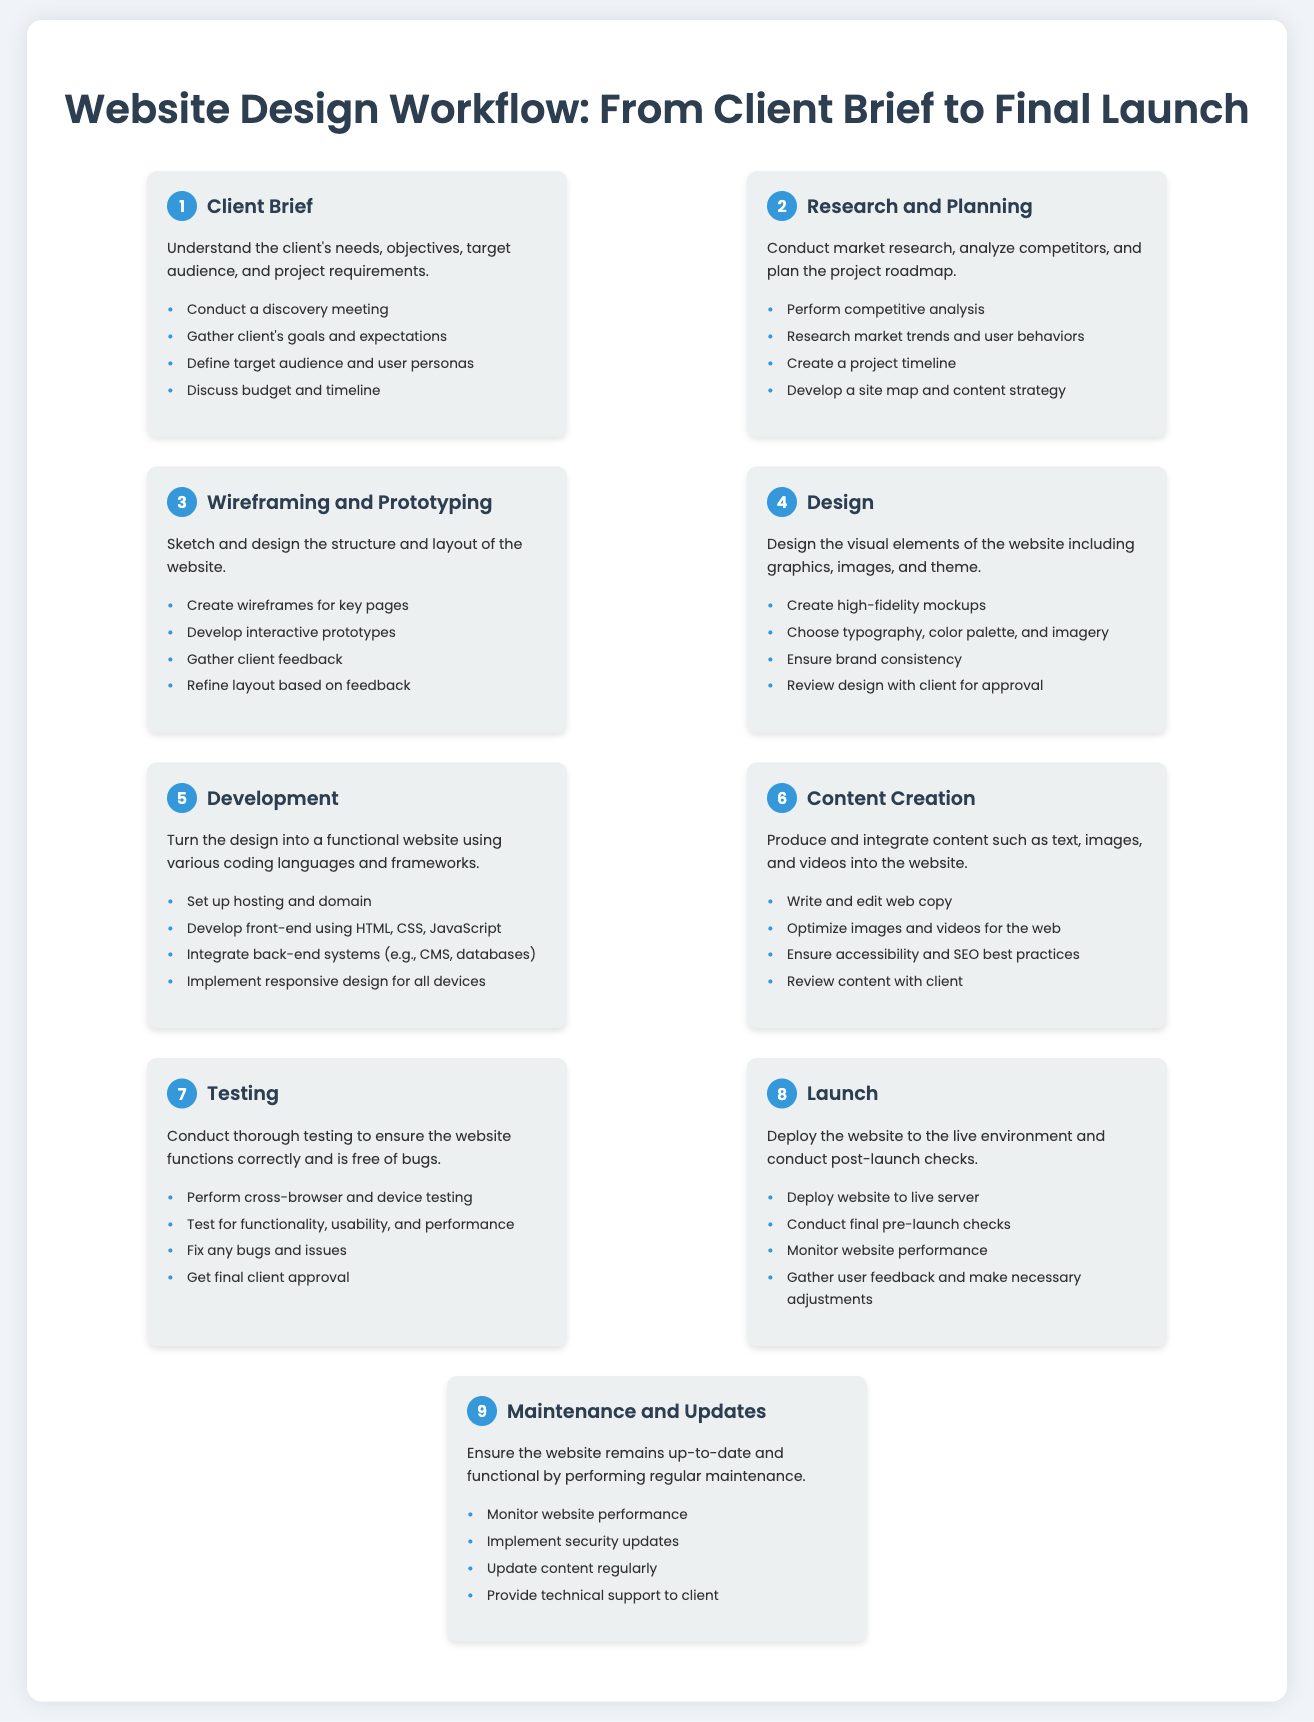What is the first step in the workflow? The first step is described in the workflow as "Client Brief", which is the initial stage in the website design process.
Answer: Client Brief How many steps are involved in the workflow? The workflow consists of a total of nine distinct steps detailing the process from start to finish.
Answer: 9 What does the "Design" step focus on? The "Design" step centers on the visual elements of the website, including graphics, images, and theme creation.
Answer: Visual elements Which step involves conducting a discovery meeting? The "Client Brief" step is where a discovery meeting is conducted to understand the client's needs and expectations.
Answer: Client Brief What is the last step mentioned in the workflow? The last step in the workflow focuses on ongoing site maintenance and updates to ensure functionality and currency.
Answer: Maintenance and Updates What action is taken during the "Testing" step? During the "Testing" step, thorough checks for functionality, usability, and performance are performed to ensure the website works correctly.
Answer: Cross-browser testing In which step do you gather client feedback on design? Client feedback on design is gathered in the "Wireframing and Prototyping" step, where prototypes are developed and refined based on feedback.
Answer: Wireframing and Prototyping What is created in the "Wireframing and Prototyping" step? In this step, wireframes for key pages and interactive prototypes are created to outline the website's structure and layout.
Answer: Wireframes and prototypes 